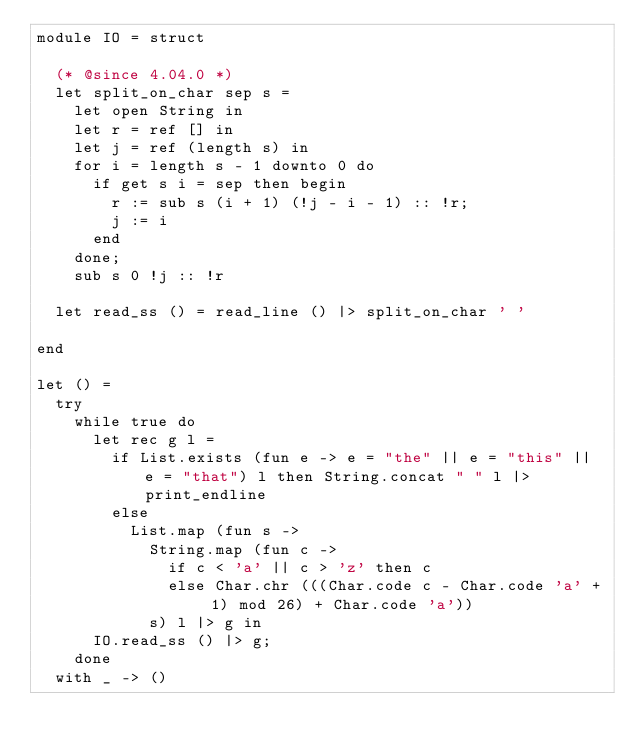<code> <loc_0><loc_0><loc_500><loc_500><_OCaml_>module IO = struct

  (* @since 4.04.0 *)
  let split_on_char sep s =
    let open String in
    let r = ref [] in
    let j = ref (length s) in
    for i = length s - 1 downto 0 do
      if get s i = sep then begin
        r := sub s (i + 1) (!j - i - 1) :: !r;
        j := i
      end
    done;
    sub s 0 !j :: !r

  let read_ss () = read_line () |> split_on_char ' '

end

let () =
  try
    while true do
      let rec g l =
        if List.exists (fun e -> e = "the" || e = "this" || e = "that") l then String.concat " " l |> print_endline
        else
          List.map (fun s ->
            String.map (fun c ->
              if c < 'a' || c > 'z' then c
              else Char.chr (((Char.code c - Char.code 'a' + 1) mod 26) + Char.code 'a'))
            s) l |> g in
      IO.read_ss () |> g;
    done
  with _ -> ()</code> 